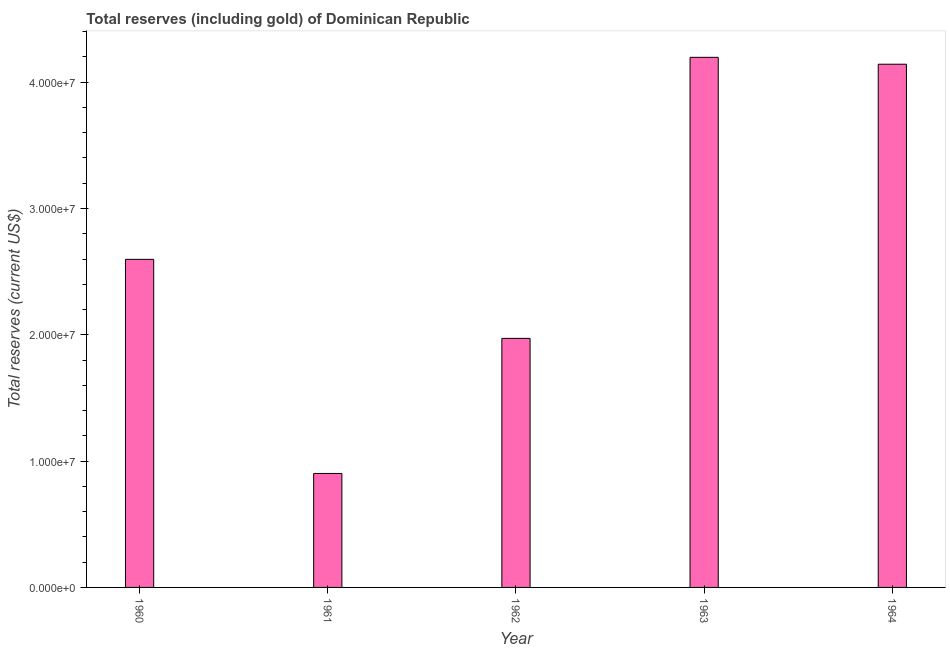Does the graph contain any zero values?
Your response must be concise. No. What is the title of the graph?
Your response must be concise. Total reserves (including gold) of Dominican Republic. What is the label or title of the X-axis?
Provide a short and direct response. Year. What is the label or title of the Y-axis?
Provide a succinct answer. Total reserves (current US$). What is the total reserves (including gold) in 1963?
Your answer should be compact. 4.20e+07. Across all years, what is the maximum total reserves (including gold)?
Keep it short and to the point. 4.20e+07. Across all years, what is the minimum total reserves (including gold)?
Offer a terse response. 9.02e+06. In which year was the total reserves (including gold) minimum?
Make the answer very short. 1961. What is the sum of the total reserves (including gold)?
Offer a very short reply. 1.38e+08. What is the difference between the total reserves (including gold) in 1961 and 1964?
Give a very brief answer. -3.24e+07. What is the average total reserves (including gold) per year?
Offer a very short reply. 2.76e+07. What is the median total reserves (including gold)?
Offer a terse response. 2.60e+07. In how many years, is the total reserves (including gold) greater than 30000000 US$?
Your answer should be compact. 2. Do a majority of the years between 1961 and 1963 (inclusive) have total reserves (including gold) greater than 34000000 US$?
Offer a very short reply. No. What is the ratio of the total reserves (including gold) in 1960 to that in 1962?
Keep it short and to the point. 1.32. Is the total reserves (including gold) in 1962 less than that in 1963?
Make the answer very short. Yes. What is the difference between the highest and the second highest total reserves (including gold)?
Give a very brief answer. 5.47e+05. Is the sum of the total reserves (including gold) in 1960 and 1962 greater than the maximum total reserves (including gold) across all years?
Your answer should be compact. Yes. What is the difference between the highest and the lowest total reserves (including gold)?
Keep it short and to the point. 3.29e+07. Are all the bars in the graph horizontal?
Provide a short and direct response. No. Are the values on the major ticks of Y-axis written in scientific E-notation?
Keep it short and to the point. Yes. What is the Total reserves (current US$) of 1960?
Provide a succinct answer. 2.60e+07. What is the Total reserves (current US$) of 1961?
Your answer should be compact. 9.02e+06. What is the Total reserves (current US$) of 1962?
Provide a succinct answer. 1.97e+07. What is the Total reserves (current US$) in 1963?
Your answer should be very brief. 4.20e+07. What is the Total reserves (current US$) in 1964?
Provide a short and direct response. 4.14e+07. What is the difference between the Total reserves (current US$) in 1960 and 1961?
Your answer should be compact. 1.70e+07. What is the difference between the Total reserves (current US$) in 1960 and 1962?
Make the answer very short. 6.26e+06. What is the difference between the Total reserves (current US$) in 1960 and 1963?
Keep it short and to the point. -1.60e+07. What is the difference between the Total reserves (current US$) in 1960 and 1964?
Offer a very short reply. -1.54e+07. What is the difference between the Total reserves (current US$) in 1961 and 1962?
Offer a terse response. -1.07e+07. What is the difference between the Total reserves (current US$) in 1961 and 1963?
Your answer should be very brief. -3.29e+07. What is the difference between the Total reserves (current US$) in 1961 and 1964?
Provide a succinct answer. -3.24e+07. What is the difference between the Total reserves (current US$) in 1962 and 1963?
Your response must be concise. -2.23e+07. What is the difference between the Total reserves (current US$) in 1962 and 1964?
Your answer should be very brief. -2.17e+07. What is the difference between the Total reserves (current US$) in 1963 and 1964?
Offer a very short reply. 5.47e+05. What is the ratio of the Total reserves (current US$) in 1960 to that in 1961?
Your response must be concise. 2.88. What is the ratio of the Total reserves (current US$) in 1960 to that in 1962?
Your answer should be very brief. 1.32. What is the ratio of the Total reserves (current US$) in 1960 to that in 1963?
Your answer should be very brief. 0.62. What is the ratio of the Total reserves (current US$) in 1960 to that in 1964?
Offer a very short reply. 0.63. What is the ratio of the Total reserves (current US$) in 1961 to that in 1962?
Provide a short and direct response. 0.46. What is the ratio of the Total reserves (current US$) in 1961 to that in 1963?
Give a very brief answer. 0.21. What is the ratio of the Total reserves (current US$) in 1961 to that in 1964?
Your response must be concise. 0.22. What is the ratio of the Total reserves (current US$) in 1962 to that in 1963?
Provide a succinct answer. 0.47. What is the ratio of the Total reserves (current US$) in 1962 to that in 1964?
Your answer should be very brief. 0.48. What is the ratio of the Total reserves (current US$) in 1963 to that in 1964?
Your answer should be very brief. 1.01. 